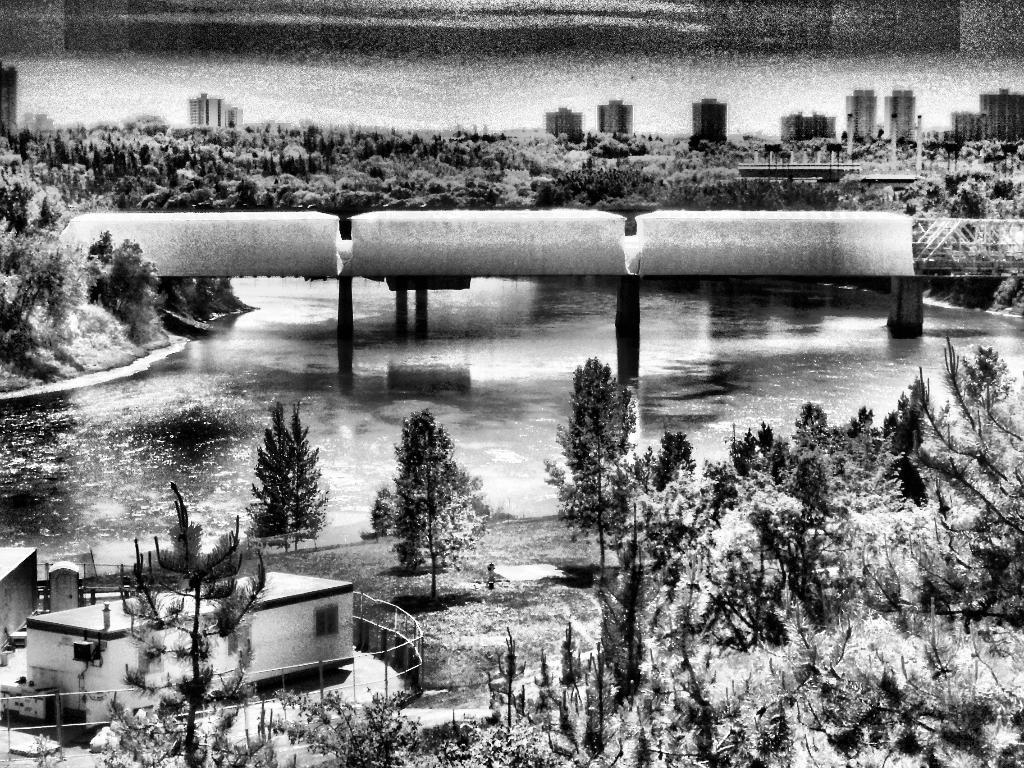Can you describe this image briefly? It is a black and white image, there are many trees and buildings and in the middle there is a water surface. On the water surface there is some construction. 